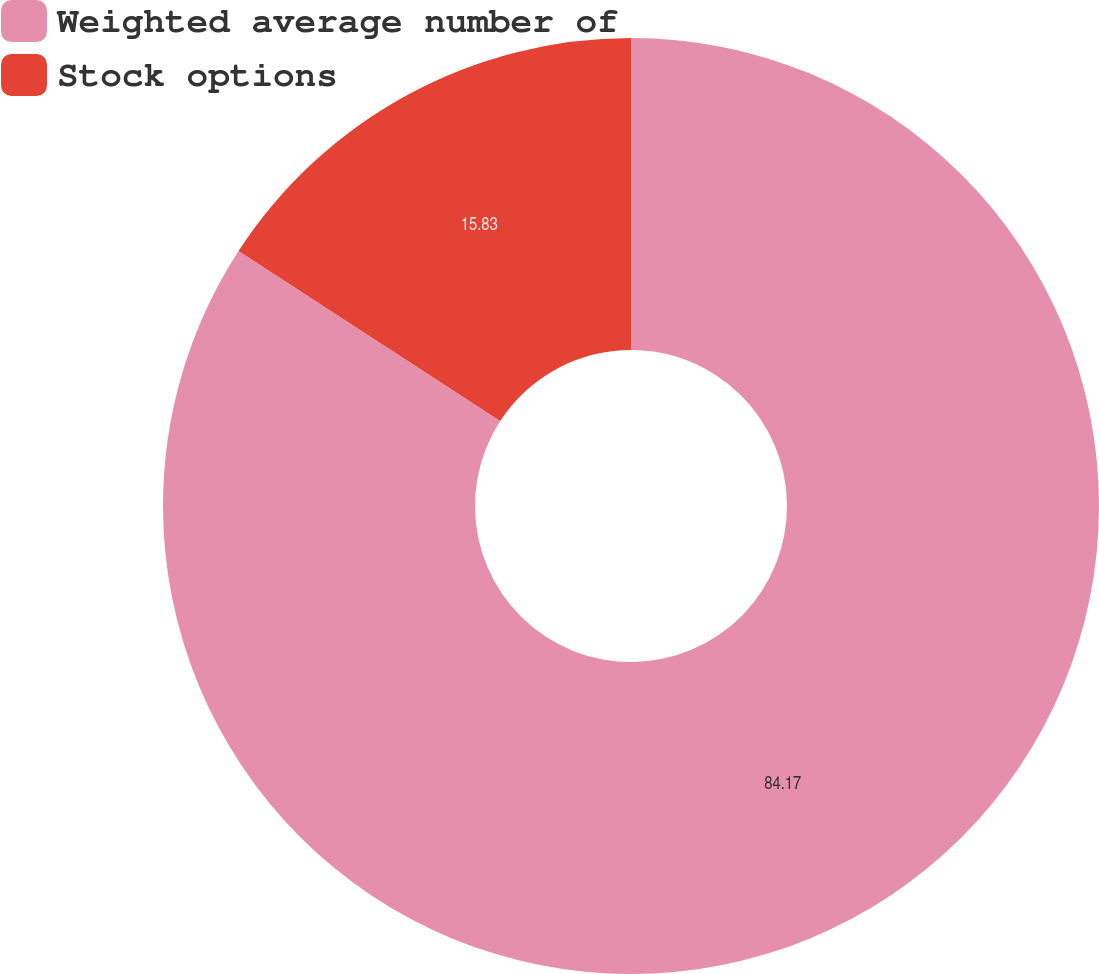Convert chart. <chart><loc_0><loc_0><loc_500><loc_500><pie_chart><fcel>Weighted average number of<fcel>Stock options<nl><fcel>84.17%<fcel>15.83%<nl></chart> 